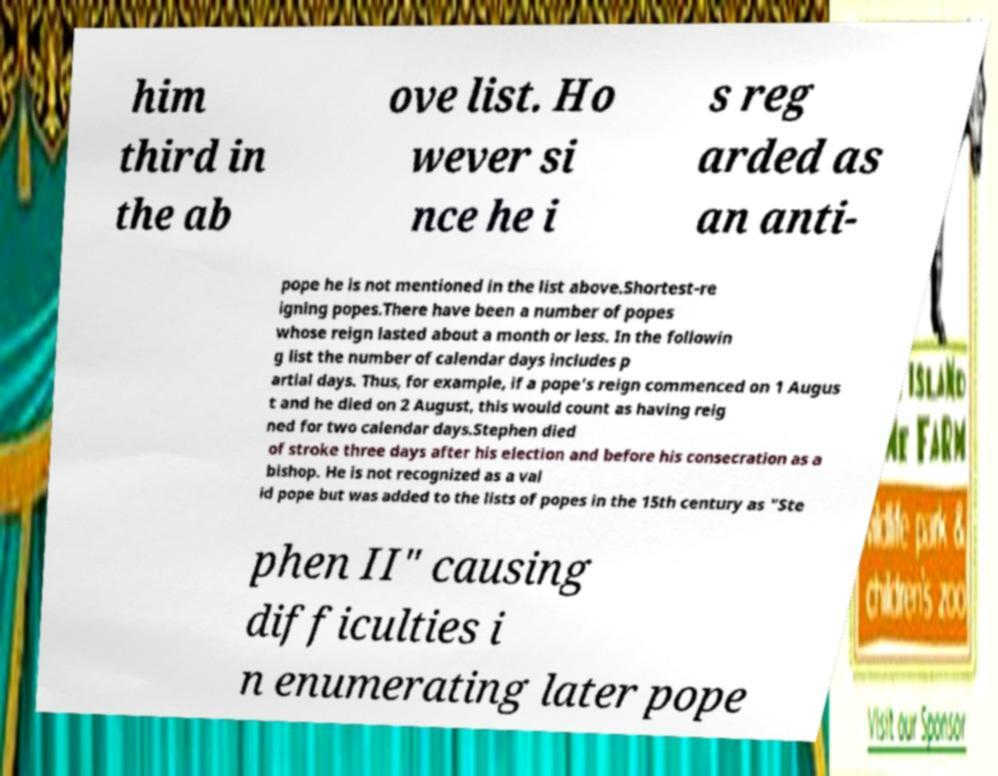What messages or text are displayed in this image? I need them in a readable, typed format. him third in the ab ove list. Ho wever si nce he i s reg arded as an anti- pope he is not mentioned in the list above.Shortest-re igning popes.There have been a number of popes whose reign lasted about a month or less. In the followin g list the number of calendar days includes p artial days. Thus, for example, if a pope's reign commenced on 1 Augus t and he died on 2 August, this would count as having reig ned for two calendar days.Stephen died of stroke three days after his election and before his consecration as a bishop. He is not recognized as a val id pope but was added to the lists of popes in the 15th century as "Ste phen II" causing difficulties i n enumerating later pope 